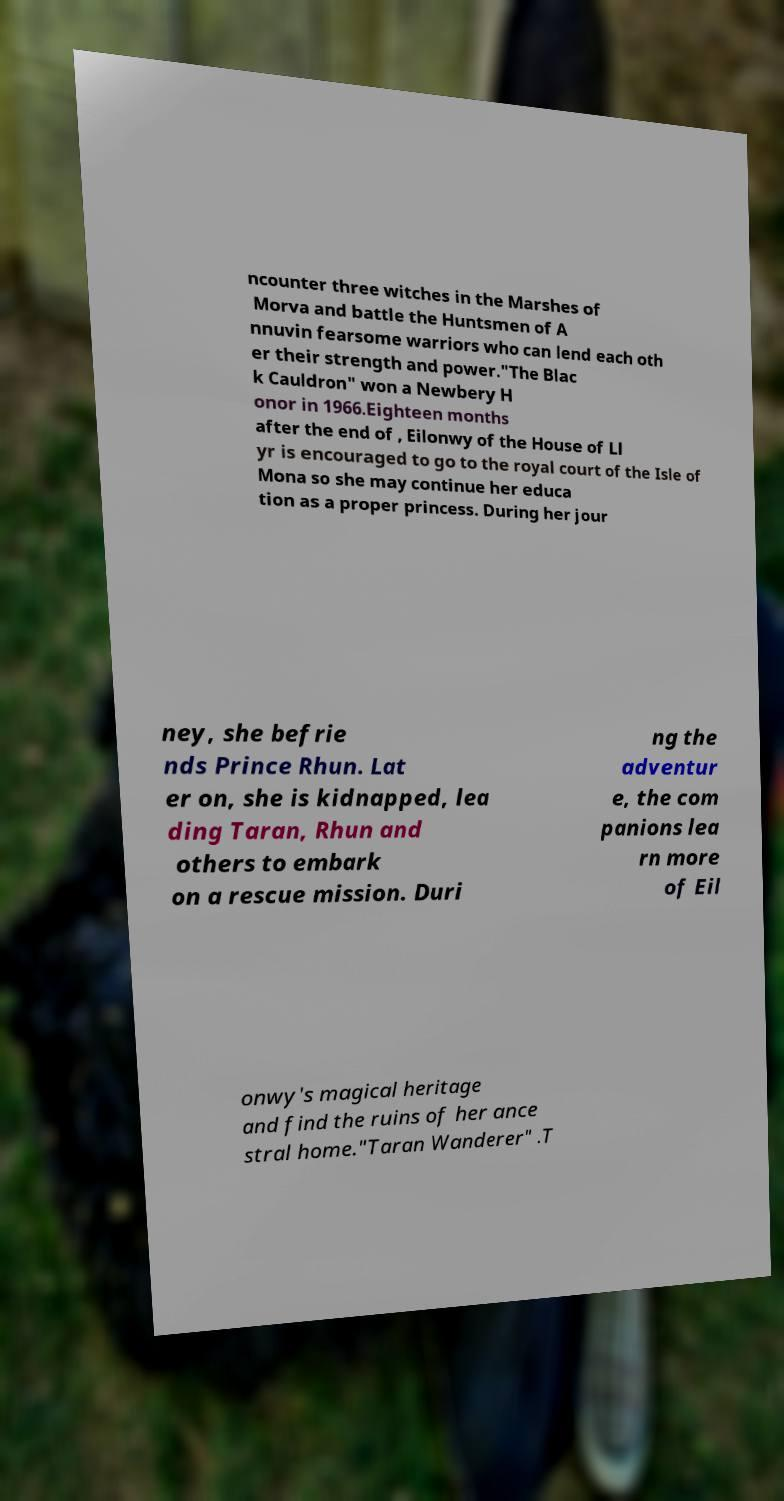There's text embedded in this image that I need extracted. Can you transcribe it verbatim? ncounter three witches in the Marshes of Morva and battle the Huntsmen of A nnuvin fearsome warriors who can lend each oth er their strength and power."The Blac k Cauldron" won a Newbery H onor in 1966.Eighteen months after the end of , Eilonwy of the House of Ll yr is encouraged to go to the royal court of the Isle of Mona so she may continue her educa tion as a proper princess. During her jour ney, she befrie nds Prince Rhun. Lat er on, she is kidnapped, lea ding Taran, Rhun and others to embark on a rescue mission. Duri ng the adventur e, the com panions lea rn more of Eil onwy's magical heritage and find the ruins of her ance stral home."Taran Wanderer" .T 